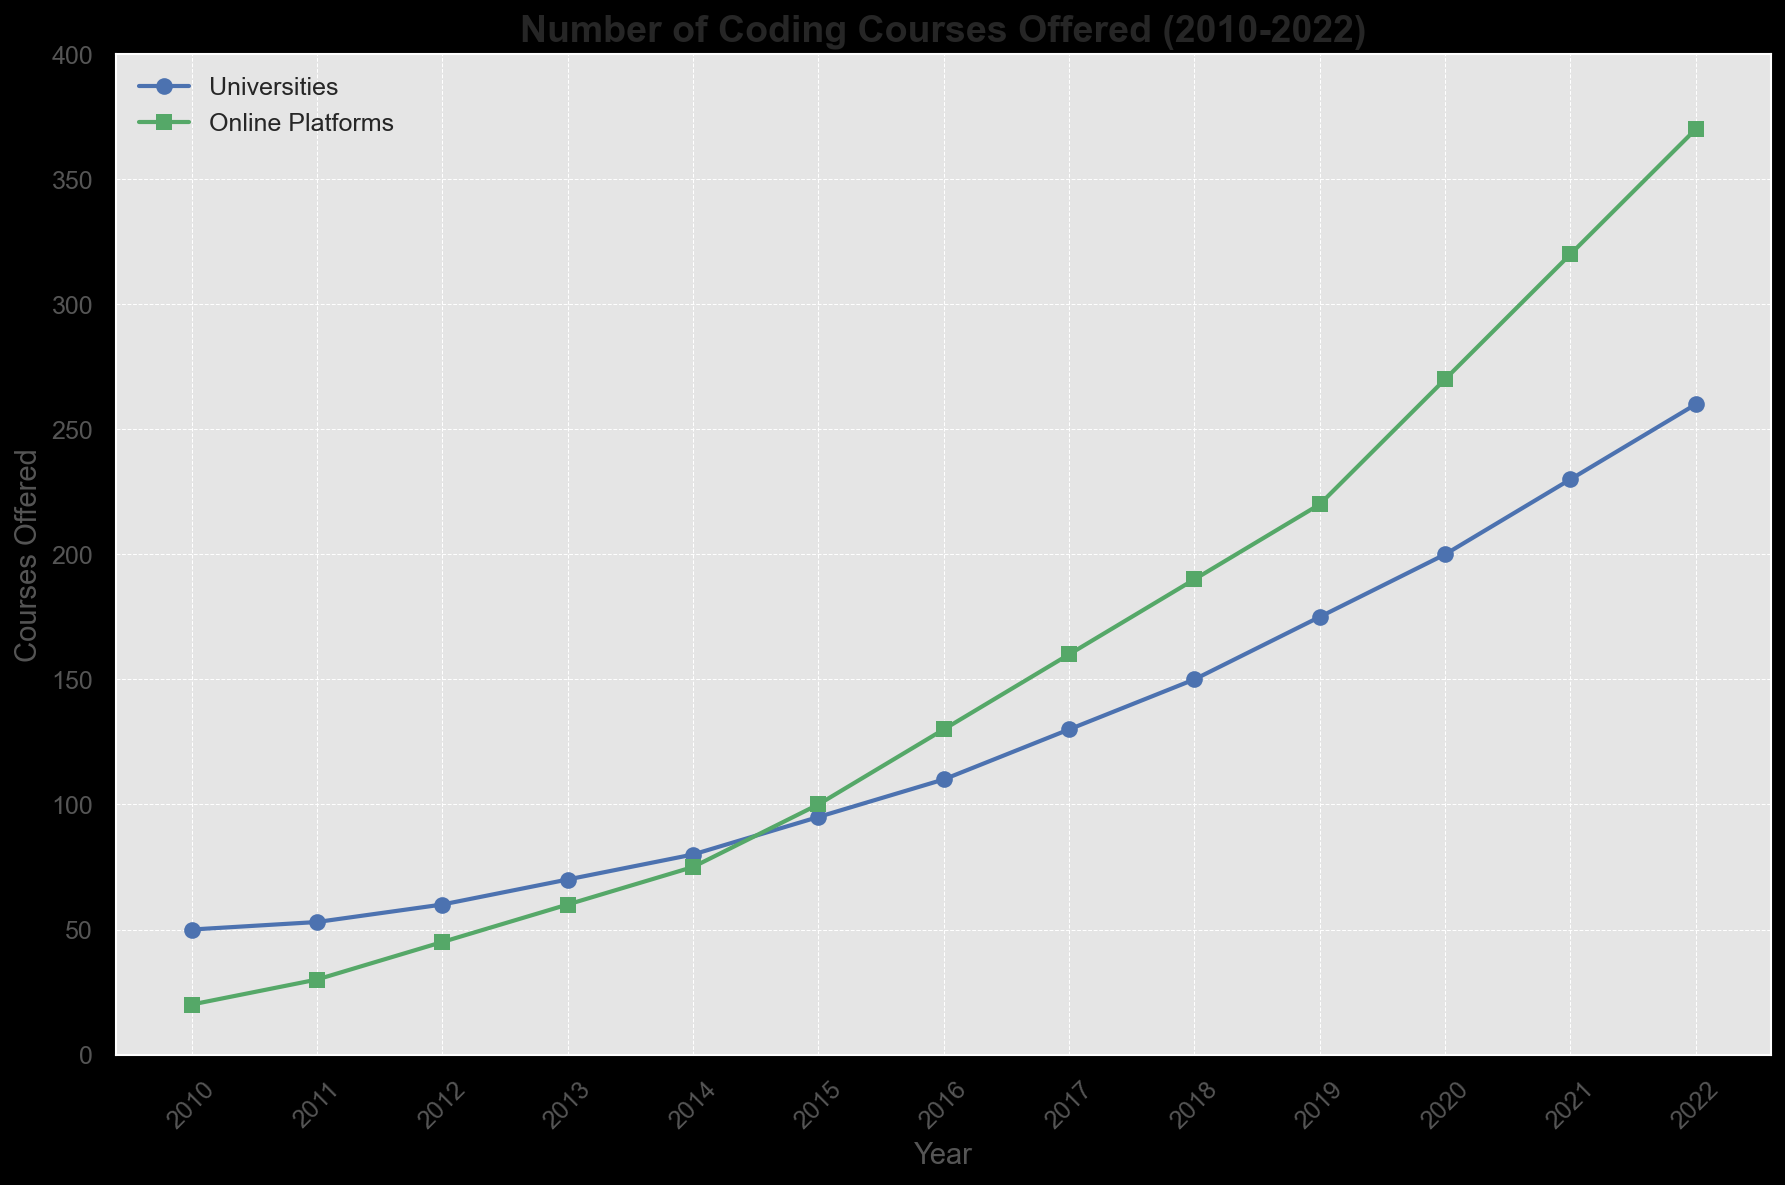What year did universities offer the same number of courses as online platforms in 2010? In 2010, online platforms offered 20 courses. By referring to the figure, universities offered 50 courses in 2010 and 53 in 2011. Looking for the year when universities offered 20 courses more than 2020, they offered around 60 courses in 2012.
Answer: 2012 Which year shows the largest year-over-year increase in the number of coding courses offered by online platforms? To find this, look at the difference in the number of coding courses each year for online platforms. The biggest jump can be found by comparing each pair of years. From 2019 to 2020, the increase is 270 - 220 = 50 courses.
Answer: 2019 to 2020 Approximately how many more courses did universities offer than online platforms in 2015? In 2015, universities offered 95 courses and online platforms offered 100 courses. The difference is 95 - 100, equating to approximately 5 courses fewer by universities.
Answer: 5 fewer When did online platforms begin to offer more courses than universities? By comparing the data year by year, online platforms begin to offer more courses than universities starting in 2014.
Answer: 2014 What is the average number of coding courses offered by universities between 2010 and 2022? Add up the number of courses for universities for each year and then divide by the number of years, i.e., (50 + 53 + 60 + 70 + 80 + 95 + 110 + 130 + 150 + 175 + 200 + 230 + 260) / 13. This gives an average of around 132.
Answer: 132 Which year shows the steep difference between these two trends? Observing the trends, the steepest difference occurs in 2022 where universities offered 260 courses, and online platforms offered 370 courses, a difference of 110.
Answer: 2022 How many total courses were offered by universities and online platforms combined in 2021? Sum the courses offered by universities (230) and online platforms (320) in 2021. The total is 230 + 320 = 550.
Answer: 550 What is the trend in the number of courses offered by universities from 2016 to 2018? From 2016 to 2018, the number of courses offered by universities increased from 110 to 150. This indicates a consistent increasing trend.
Answer: Increasing Trend In 2013, compare the number of courses offered by universities to those offered in 2017. In 2013, universities offered 70 courses. In 2017, they offered 130 courses, which is 130 - 70 = 60 more courses than in 2013.
Answer: 60 more What is the percentage increase in the number of courses offered by online platforms from 2010 to 2022? The increase is calculated as (370 - 20) / 20 * 100%, which equals 1750%.
Answer: 1750% 